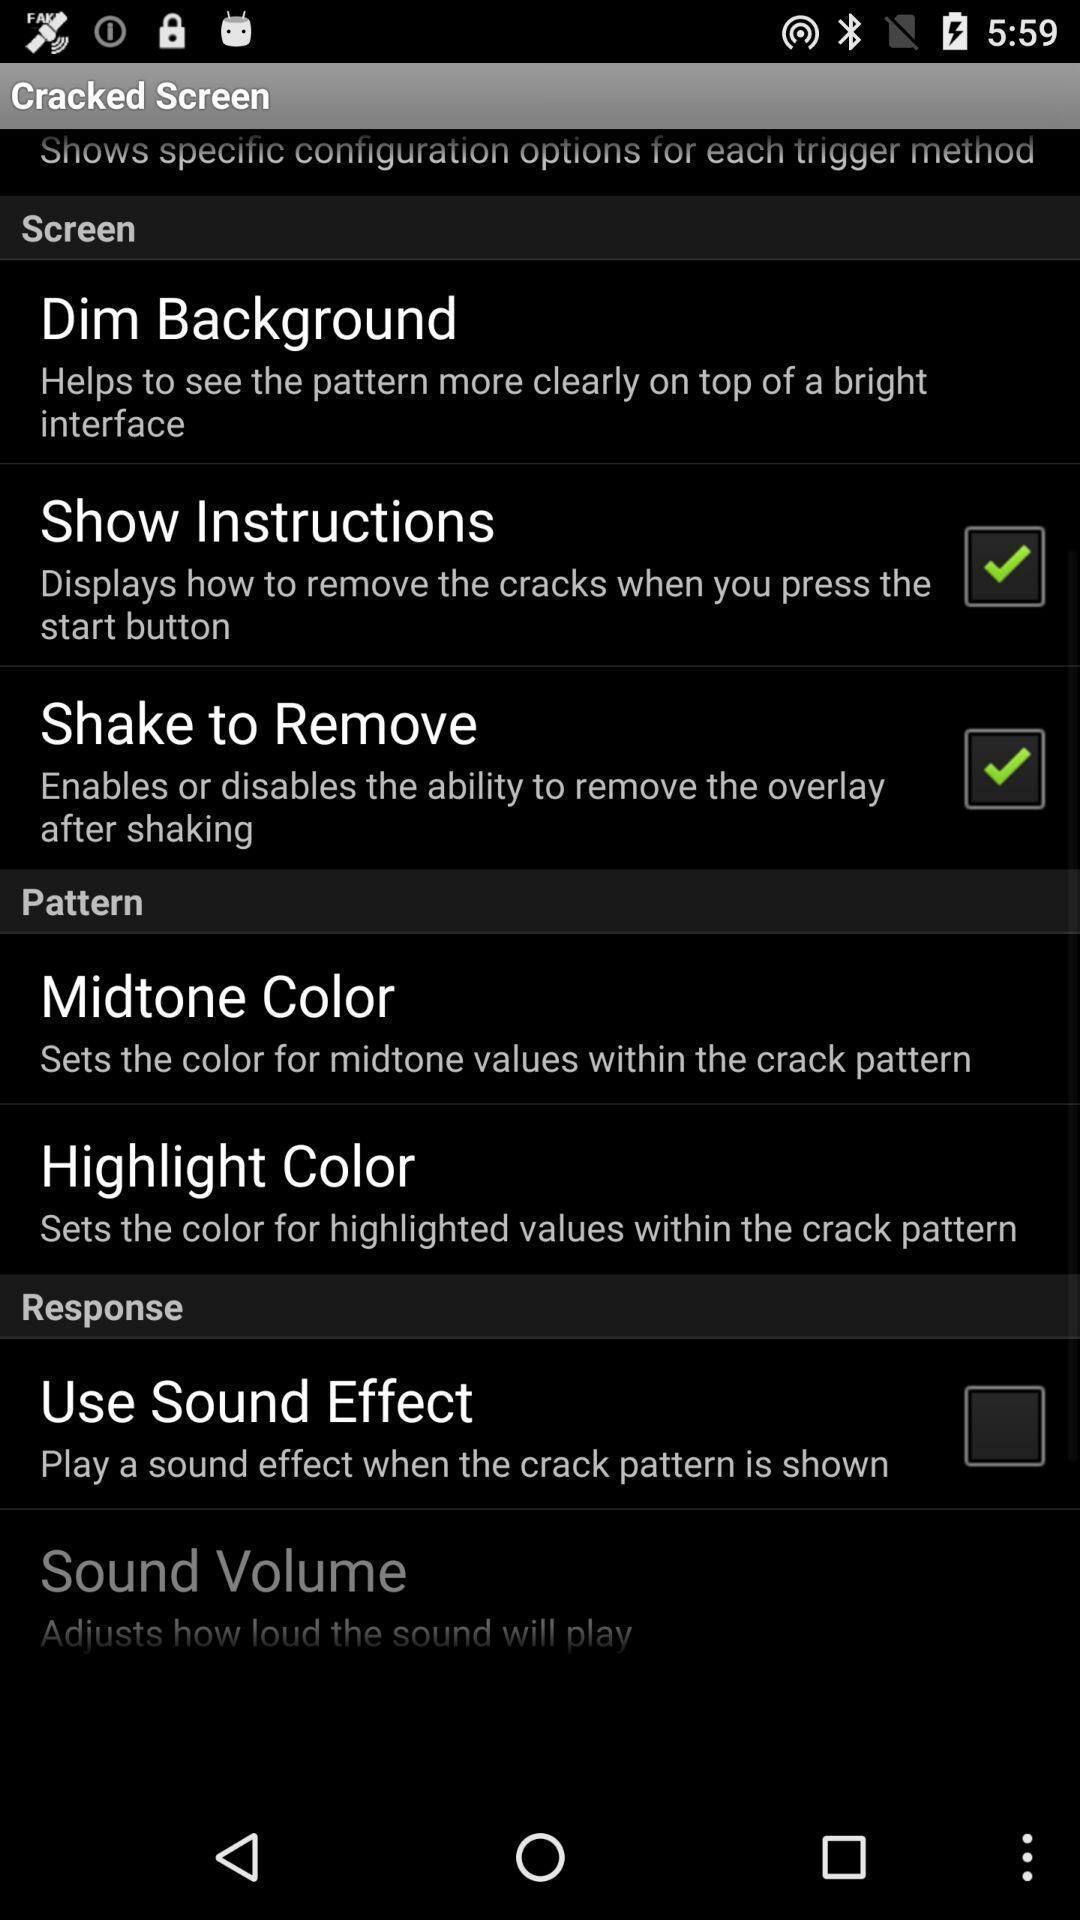Summarize the information in this screenshot. Settings page. 